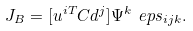Convert formula to latex. <formula><loc_0><loc_0><loc_500><loc_500>J _ { B } = [ u ^ { i T } C d ^ { j } ] \Psi ^ { k } \ e p s _ { i j k } .</formula> 